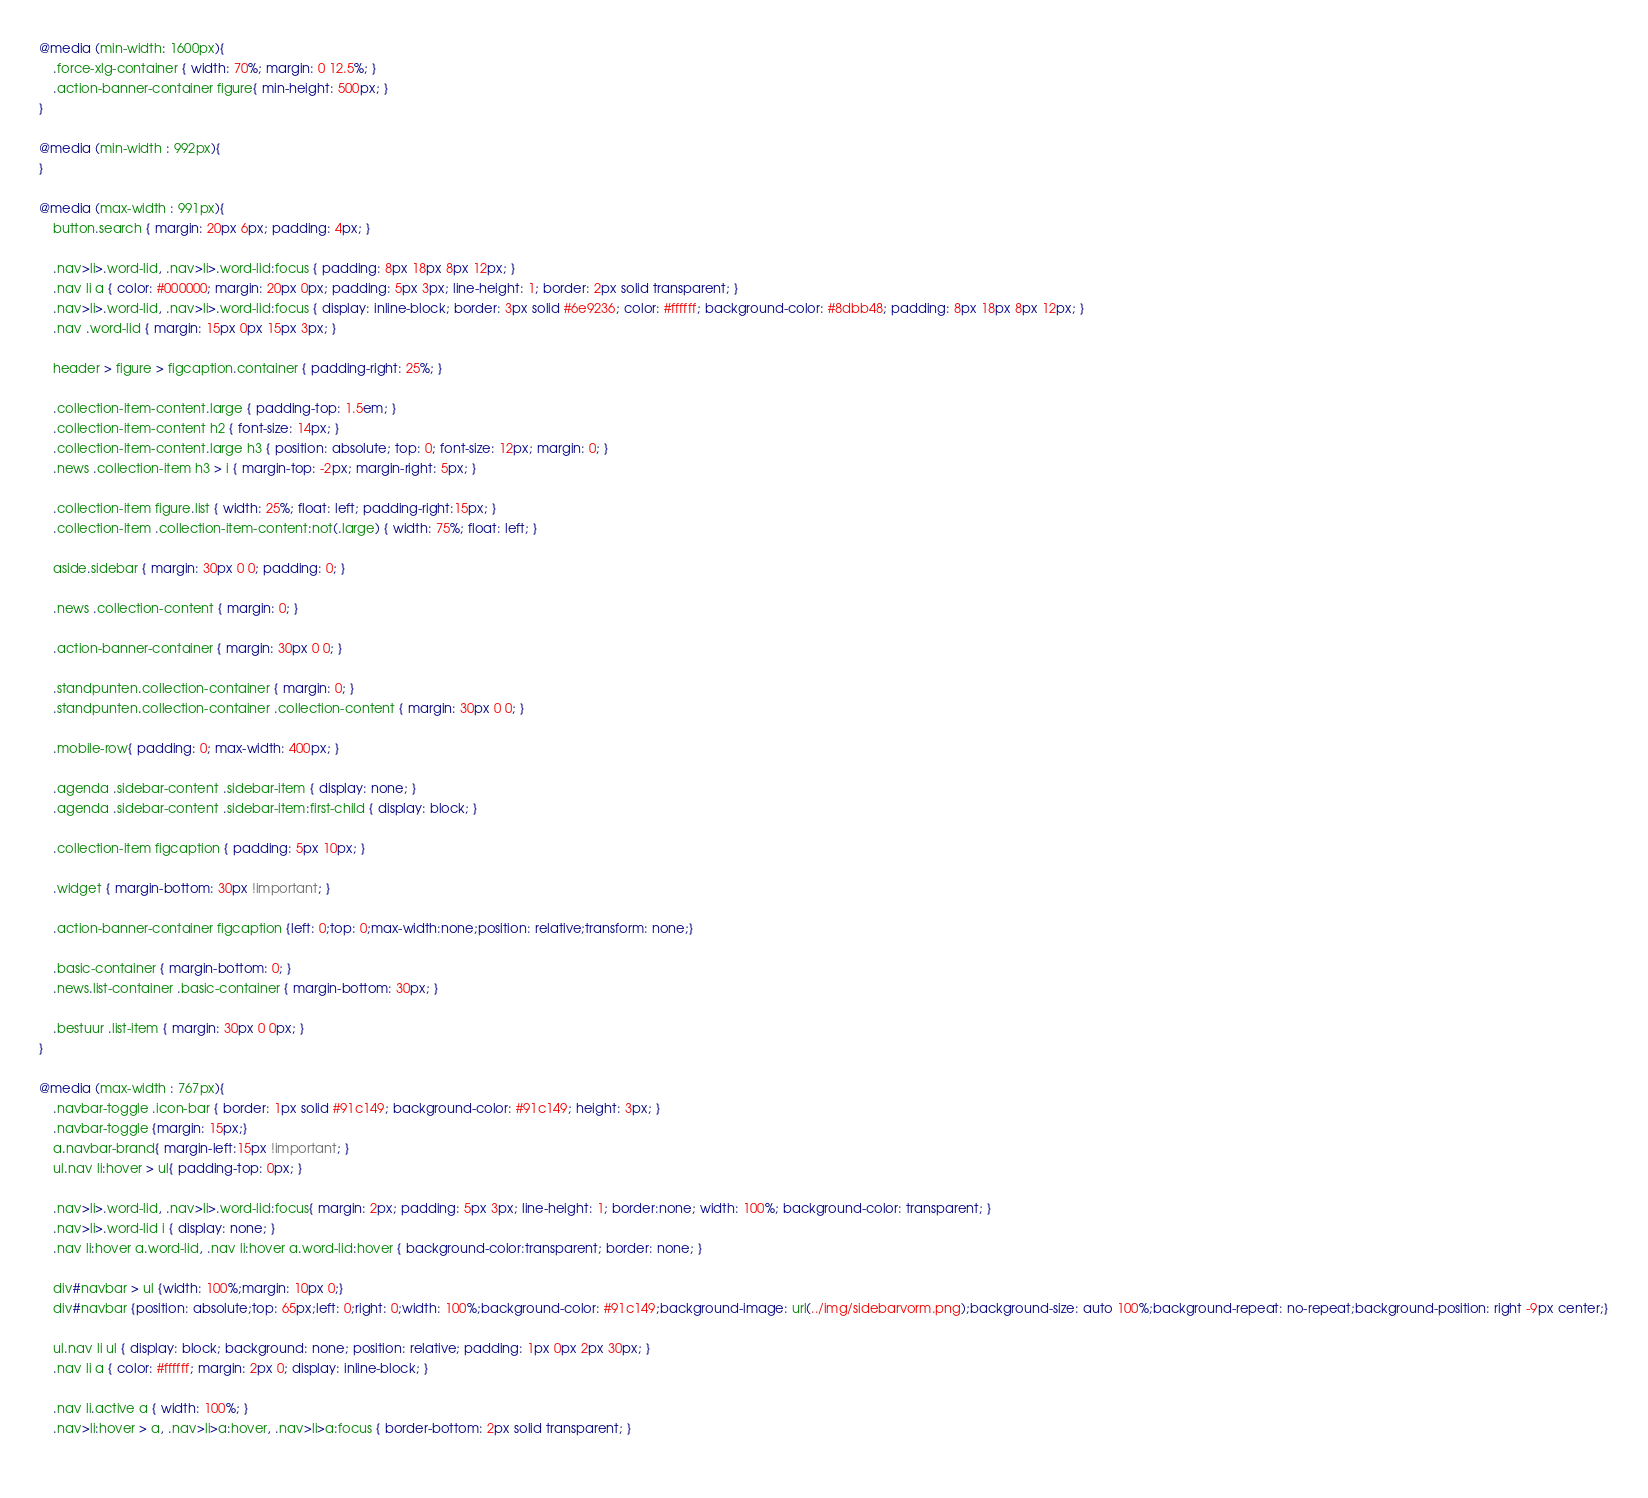<code> <loc_0><loc_0><loc_500><loc_500><_CSS_>@media (min-width: 1600px){
    .force-xlg-container { width: 70%; margin: 0 12.5%; }
    .action-banner-container figure{ min-height: 500px; }
}

@media (min-width : 992px){
}

@media (max-width : 991px){
    button.search { margin: 20px 6px; padding: 4px; }
    
    .nav>li>.word-lid, .nav>li>.word-lid:focus { padding: 8px 18px 8px 12px; }
    .nav li a { color: #000000; margin: 20px 0px; padding: 5px 3px; line-height: 1; border: 2px solid transparent; }
    .nav>li>.word-lid, .nav>li>.word-lid:focus { display: inline-block; border: 3px solid #6e9236; color: #ffffff; background-color: #8dbb48; padding: 8px 18px 8px 12px; }
    .nav .word-lid { margin: 15px 0px 15px 3px; }

    header > figure > figcaption.container { padding-right: 25%; }

    .collection-item-content.large { padding-top: 1.5em; }
    .collection-item-content h2 { font-size: 14px; }
    .collection-item-content.large h3 { position: absolute; top: 0; font-size: 12px; margin: 0; }
    .news .collection-item h3 > i { margin-top: -2px; margin-right: 5px; }

    .collection-item figure.list { width: 25%; float: left; padding-right:15px; }
    .collection-item .collection-item-content:not(.large) { width: 75%; float: left; }

    aside.sidebar { margin: 30px 0 0; padding: 0; }

    .news .collection-content { margin: 0; }

    .action-banner-container { margin: 30px 0 0; }

    .standpunten.collection-container { margin: 0; }
    .standpunten.collection-container .collection-content { margin: 30px 0 0; }

    .mobile-row{ padding: 0; max-width: 400px; }

    .agenda .sidebar-content .sidebar-item { display: none; }
    .agenda .sidebar-content .sidebar-item:first-child { display: block; }

    .collection-item figcaption { padding: 5px 10px; }

    .widget { margin-bottom: 30px !important; }

    .action-banner-container figcaption {left: 0;top: 0;max-width:none;position: relative;transform: none;}

    .basic-container { margin-bottom: 0; }
    .news.list-container .basic-container { margin-bottom: 30px; }

    .bestuur .list-item { margin: 30px 0 0px; }
}

@media (max-width : 767px){
    .navbar-toggle .icon-bar { border: 1px solid #91c149; background-color: #91c149; height: 3px; }
    .navbar-toggle {margin: 15px;}
    a.navbar-brand{ margin-left:15px !important; }
    ul.nav li:hover > ul{ padding-top: 0px; }

    .nav>li>.word-lid, .nav>li>.word-lid:focus{ margin: 2px; padding: 5px 3px; line-height: 1; border:none; width: 100%; background-color: transparent; }
    .nav>li>.word-lid i { display: none; }
    .nav li:hover a.word-lid, .nav li:hover a.word-lid:hover { background-color:transparent; border: none; }

    div#navbar > ul {width: 100%;margin: 10px 0;}
    div#navbar {position: absolute;top: 65px;left: 0;right: 0;width: 100%;background-color: #91c149;background-image: url(../img/sidebarvorm.png);background-size: auto 100%;background-repeat: no-repeat;background-position: right -9px center;}

    ul.nav li ul { display: block; background: none; position: relative; padding: 1px 0px 2px 30px; }
    .nav li a { color: #ffffff; margin: 2px 0; display: inline-block; }

    .nav li.active a { width: 100%; }
    .nav>li:hover > a, .nav>li>a:hover, .nav>li>a:focus { border-bottom: 2px solid transparent; }
    </code> 